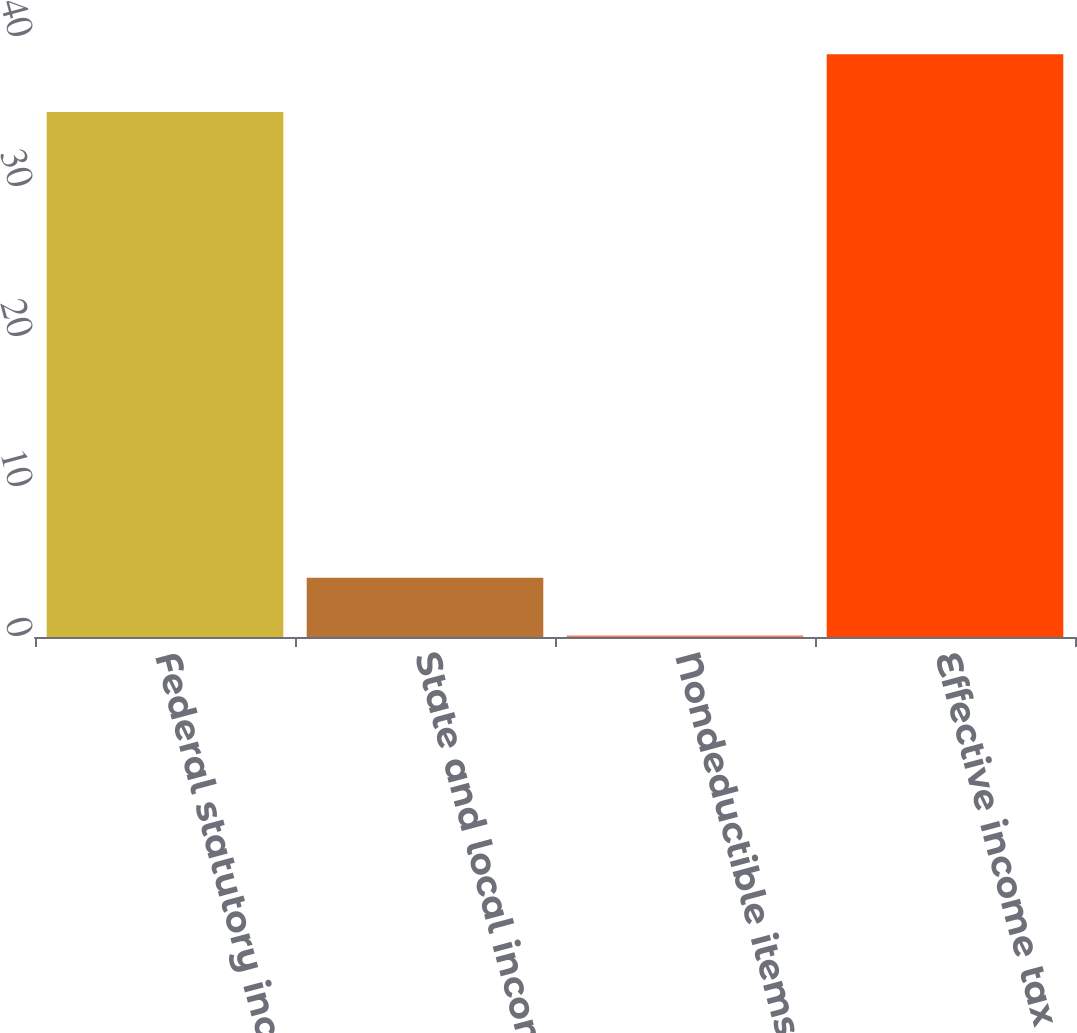Convert chart. <chart><loc_0><loc_0><loc_500><loc_500><bar_chart><fcel>Federal statutory income tax<fcel>State and local income taxes<fcel>Nondeductible items<fcel>Effective income tax rate<nl><fcel>35<fcel>3.95<fcel>0.1<fcel>38.85<nl></chart> 